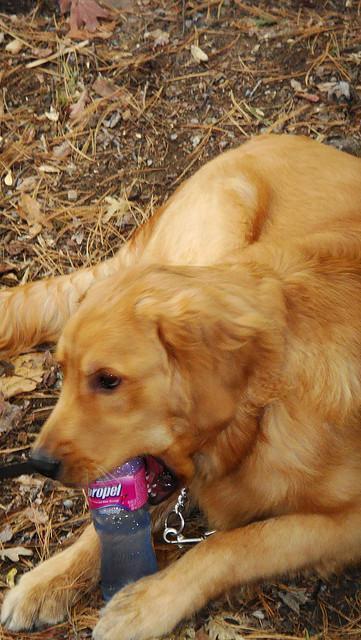How many people are in this picture?
Give a very brief answer. 0. 